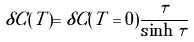Convert formula to latex. <formula><loc_0><loc_0><loc_500><loc_500>\delta C ( T ) = \delta C ( T = 0 ) \frac { \tau } { \sinh \tau }</formula> 